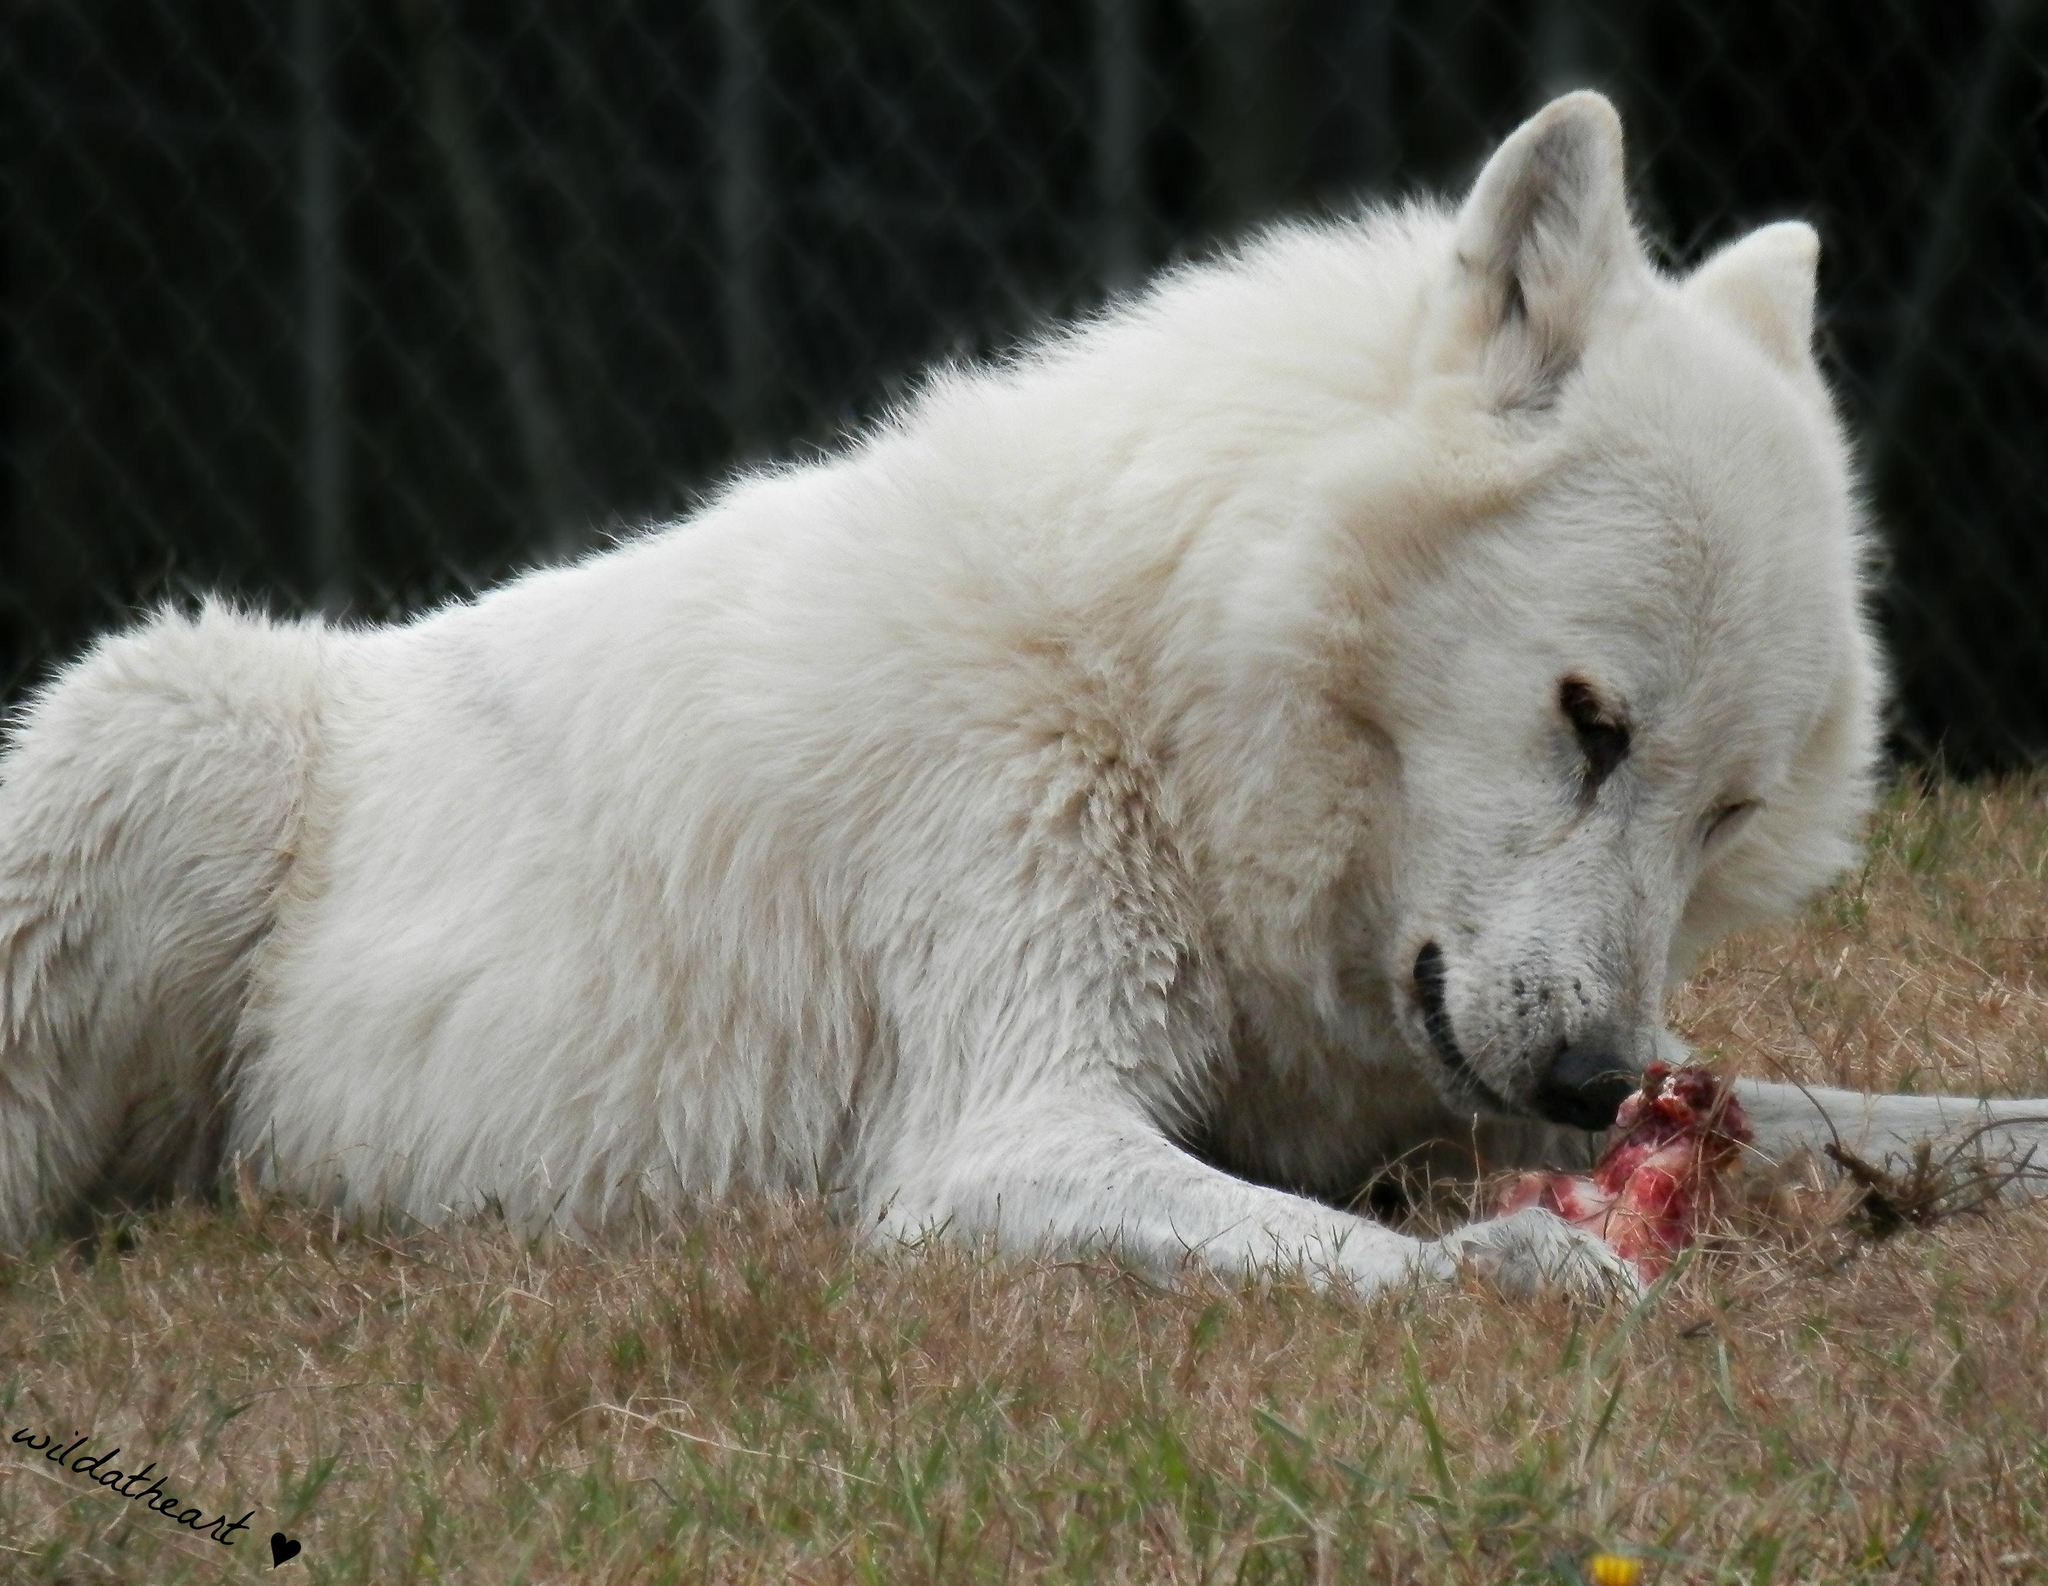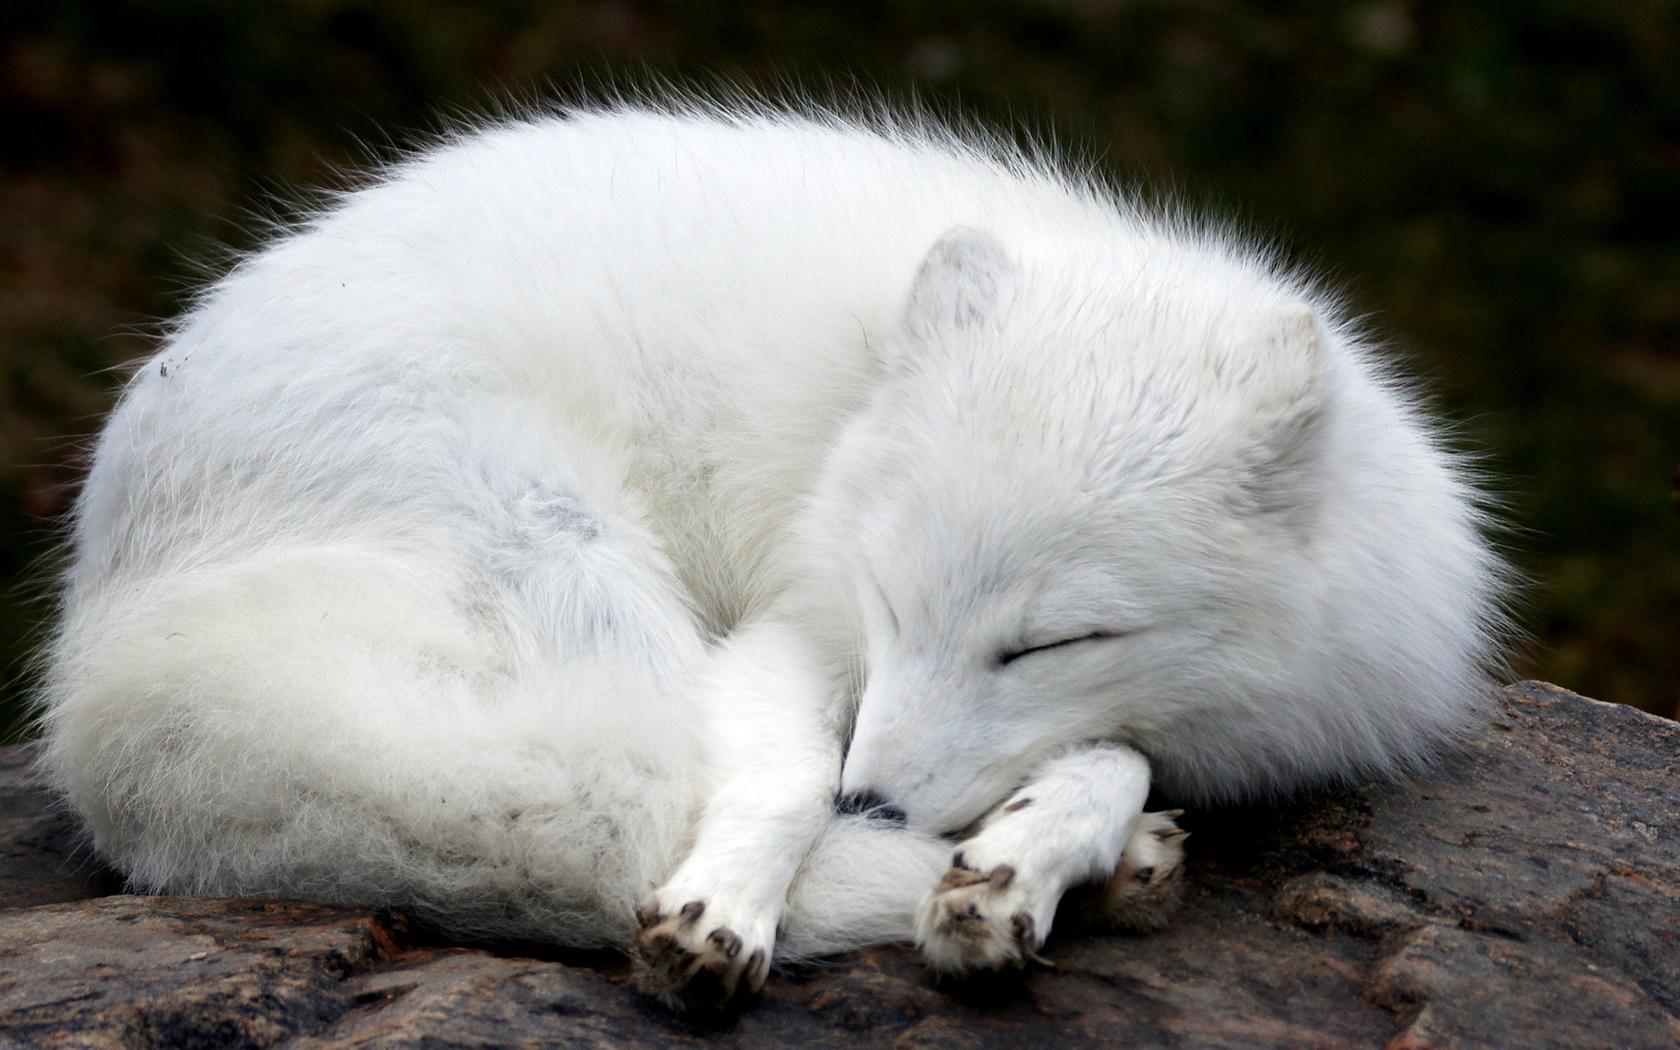The first image is the image on the left, the second image is the image on the right. Examine the images to the left and right. Is the description "Each image shows a reclining white dog with fully closed eyes, and the dogs in the left and right images look similar in terms of size, coloring, breed and ear position." accurate? Answer yes or no. No. The first image is the image on the left, the second image is the image on the right. For the images displayed, is the sentence "At least one white wolf has its eyes open." factually correct? Answer yes or no. Yes. 